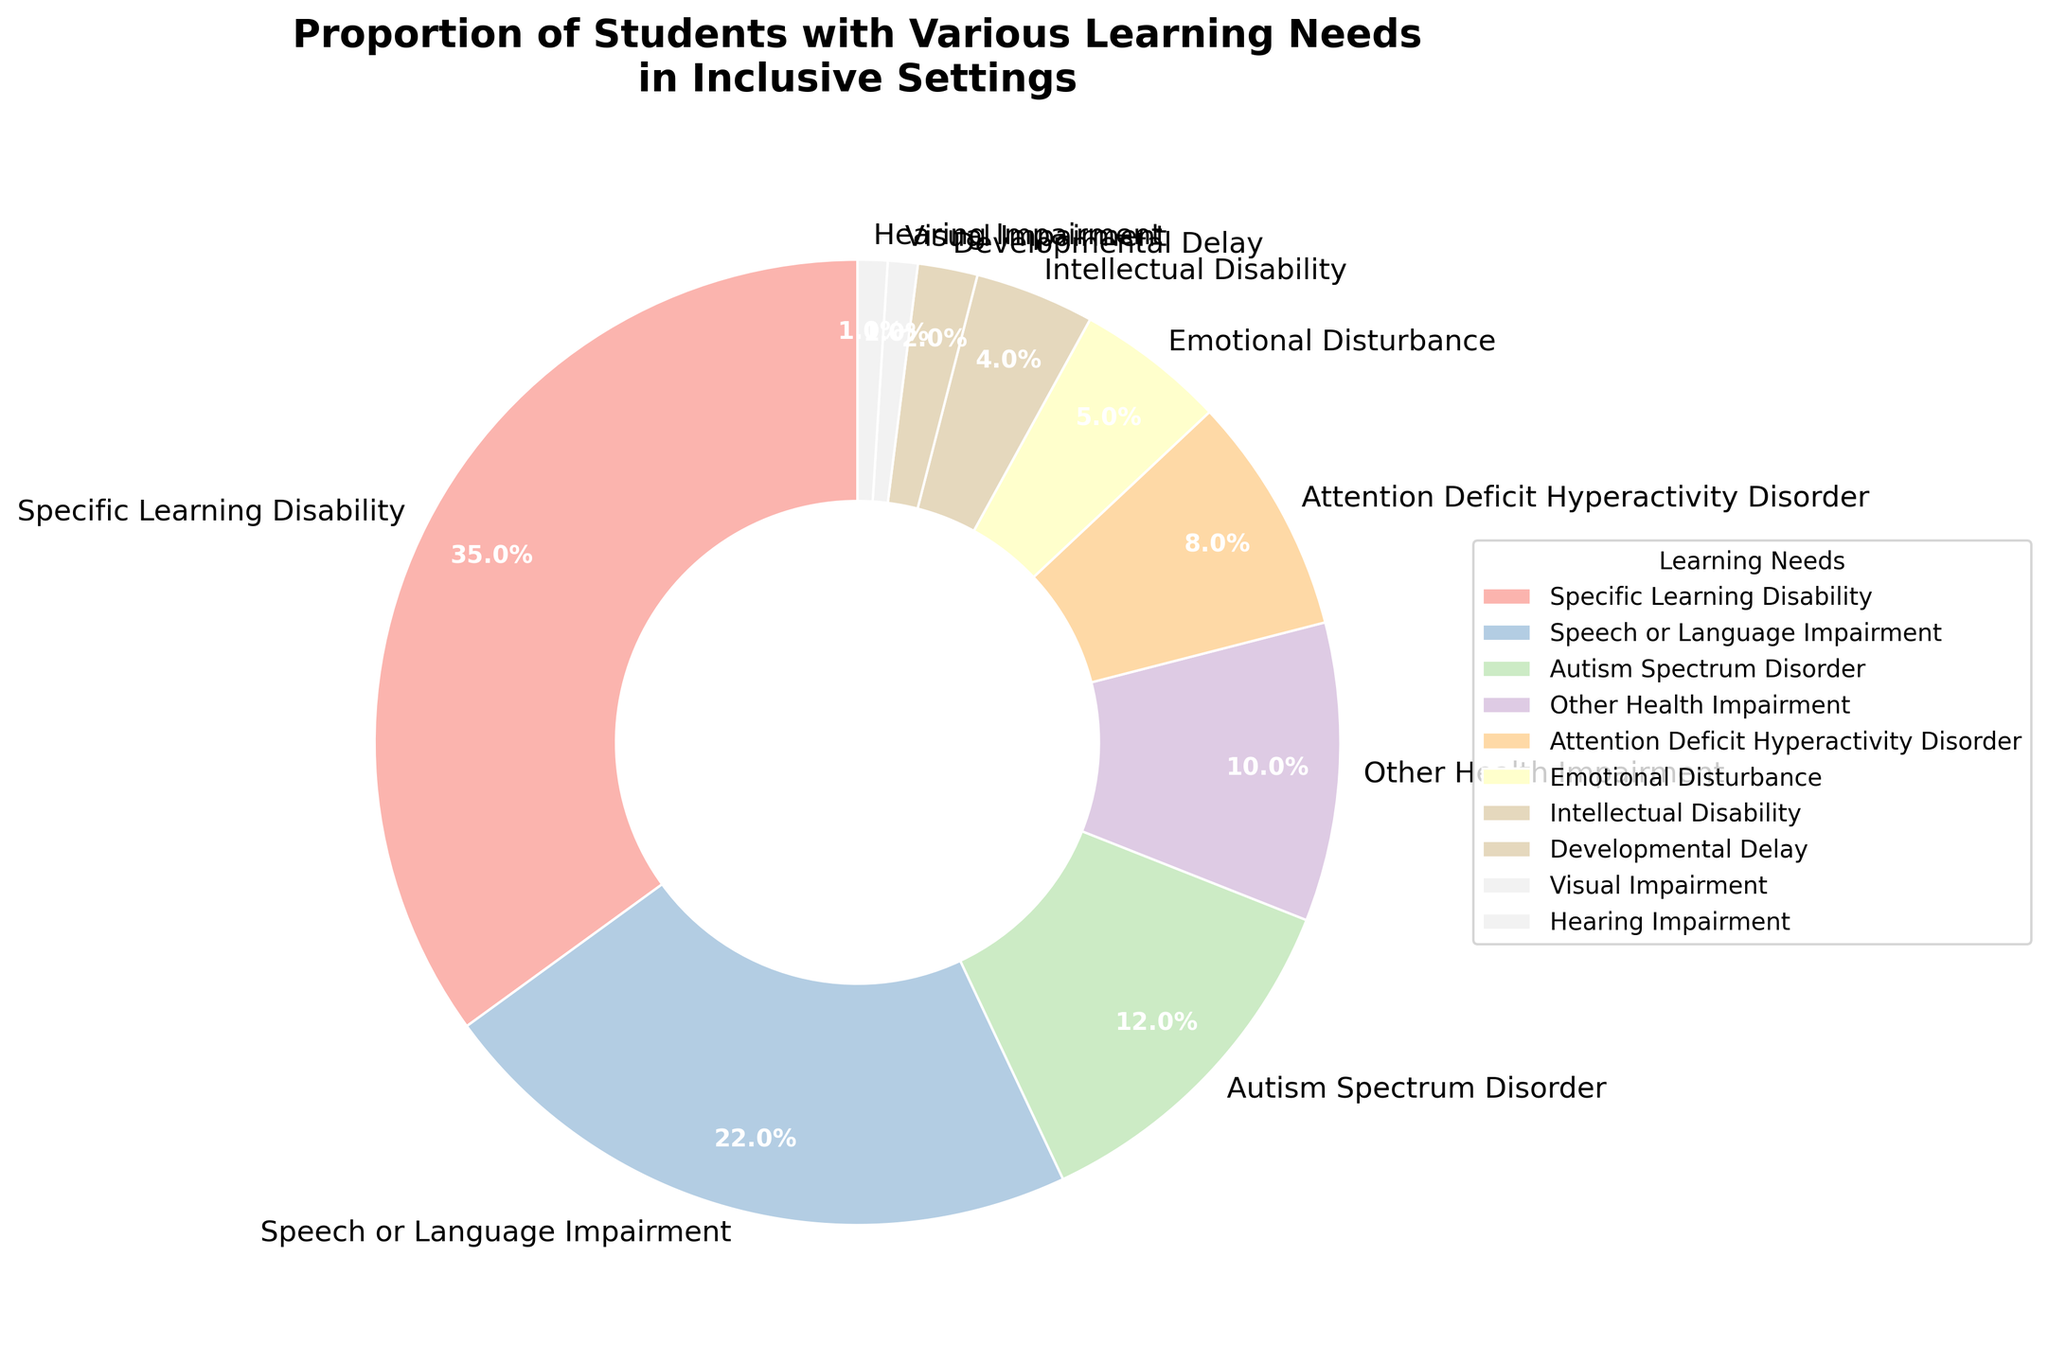Which learning need has the highest proportion of students in inclusive settings? To find this answer, look at the pie chart and identify the largest segment. The largest segment is labeled "Specific Learning Disability."
Answer: Specific Learning Disability What is the combined percentage of students with Autism Spectrum Disorder and Emotional Disturbance? Find the percentages for both Autism Spectrum Disorder (12%) and Emotional Disturbance (5%) and add them together: 12% + 5% = 17%.
Answer: 17% Which learning need has a lower proportion of students, Visual Impairment or Hearing Impairment? Compare the sizes of the segments for Visual Impairment (1%) and Hearing Impairment (1%). Both have the same proportion.
Answer: Equal How much larger is the proportion of students with Speech or Language Impairment compared to those with Attention Deficit Hyperactivity Disorder? Find the difference between the percentages for Speech or Language Impairment (22%) and Attention Deficit Hyperactivity Disorder (8%): 22% - 8% = 14%.
Answer: 14% What is the total proportion of students with Specific Learning Disability, Autism Spectrum Disorder, and Other Health Impairment? Add the percentages for Specific Learning Disability (35%), Autism Spectrum Disorder (12%), and Other Health Impairment (10%): 35% + 12% + 10% = 57%.
Answer: 57% Which three learning needs have the lowest proportions and what are their combined percentage? Identify the three smallest segments: Developmental Delay (2%), Visual Impairment (1%), and Hearing Impairment (1%). Add these together: 2% + 1% + 1% = 4%.
Answer: 4% What is the difference in proportion between students with Specific Learning Disability and Emotional Disturbance? Subtract the percentage of Emotional Disturbance (5%) from Specific Learning Disability (35%): 35% - 5% = 30%.
Answer: 30% Which group has a higher proportion, students with Speech or Language Impairment or students with Autism Spectrum Disorder and Other Health Impairment combined? Add the percentages for Autism Spectrum Disorder (12%) and Other Health Impairment (10%) to get 22%. Compare this with Speech or Language Impairment (22%). Both are equal.
Answer: Equal What proportion of students have either Intellectual Disability or Developmental Delay? Add the percentages for Intellectual Disability (4%) and Developmental Delay (2%): 4% + 2% = 6%.
Answer: 6% If you sum the proportions of students with Specific Learning Disability, Speech or Language Impairment, and Attention Deficit Hyperactivity Disorder, what do you get? Add the percentages for Specific Learning Disability (35%), Speech or Language Impairment (22%), and Attention Deficit Hyperactivity Disorder (8%): 35% + 22% + 8% = 65%.
Answer: 65% 